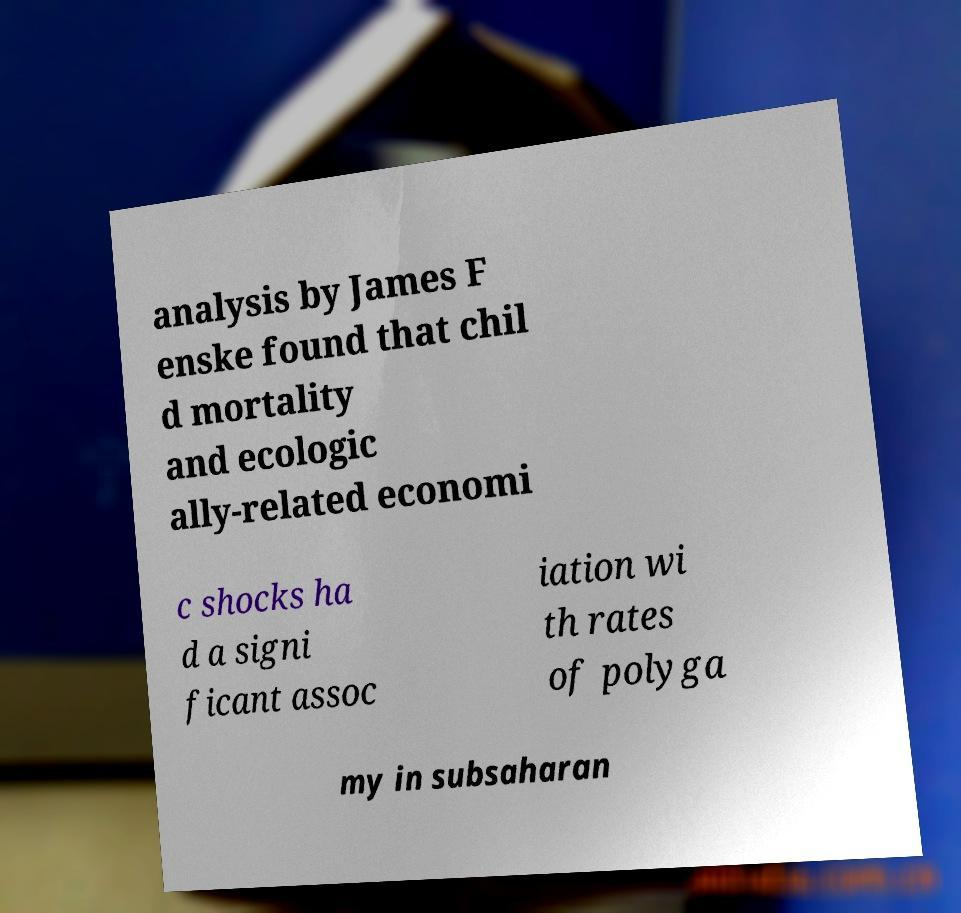Can you accurately transcribe the text from the provided image for me? analysis by James F enske found that chil d mortality and ecologic ally-related economi c shocks ha d a signi ficant assoc iation wi th rates of polyga my in subsaharan 